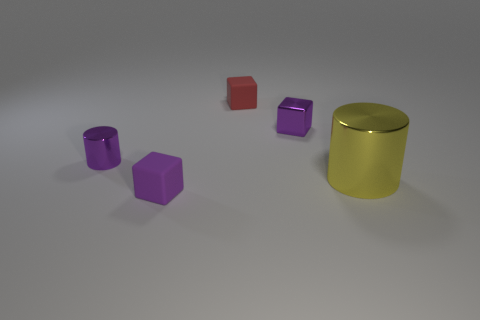Does the large yellow cylinder have the same material as the tiny purple cylinder?
Offer a very short reply. Yes. There is a tiny rubber cube that is in front of the large yellow metal cylinder; what number of purple blocks are to the left of it?
Keep it short and to the point. 0. Is the size of the red matte block the same as the purple cylinder?
Offer a very short reply. Yes. How many small things are made of the same material as the yellow cylinder?
Provide a succinct answer. 2. The other metal object that is the same shape as the tiny red object is what size?
Your response must be concise. Small. There is a thing that is in front of the big metal cylinder; is its shape the same as the red matte object?
Your response must be concise. Yes. The small purple metal thing that is to the left of the purple cube that is in front of the shiny block is what shape?
Keep it short and to the point. Cylinder. There is a metallic object that is the same shape as the tiny purple rubber thing; what is its color?
Keep it short and to the point. Purple. Does the tiny metal cylinder have the same color as the small metal object that is on the right side of the small purple matte block?
Ensure brevity in your answer.  Yes. What is the shape of the thing that is in front of the small cylinder and left of the red thing?
Offer a terse response. Cube. 